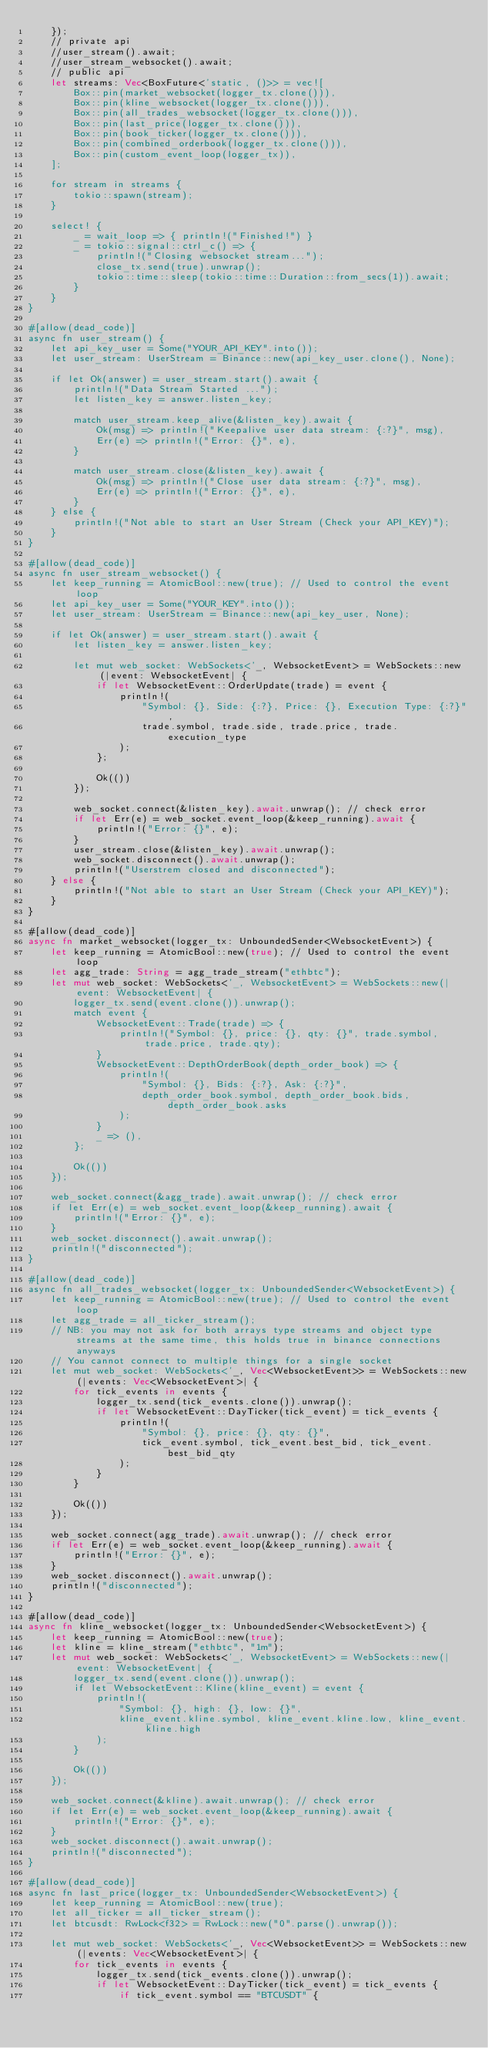Convert code to text. <code><loc_0><loc_0><loc_500><loc_500><_Rust_>    });
    // private api
    //user_stream().await;
    //user_stream_websocket().await;
    // public api
    let streams: Vec<BoxFuture<'static, ()>> = vec![
        Box::pin(market_websocket(logger_tx.clone())),
        Box::pin(kline_websocket(logger_tx.clone())),
        Box::pin(all_trades_websocket(logger_tx.clone())),
        Box::pin(last_price(logger_tx.clone())),
        Box::pin(book_ticker(logger_tx.clone())),
        Box::pin(combined_orderbook(logger_tx.clone())),
        Box::pin(custom_event_loop(logger_tx)),
    ];

    for stream in streams {
        tokio::spawn(stream);
    }

    select! {
        _ = wait_loop => { println!("Finished!") }
        _ = tokio::signal::ctrl_c() => {
            println!("Closing websocket stream...");
            close_tx.send(true).unwrap();
            tokio::time::sleep(tokio::time::Duration::from_secs(1)).await;
        }
    }
}

#[allow(dead_code)]
async fn user_stream() {
    let api_key_user = Some("YOUR_API_KEY".into());
    let user_stream: UserStream = Binance::new(api_key_user.clone(), None);

    if let Ok(answer) = user_stream.start().await {
        println!("Data Stream Started ...");
        let listen_key = answer.listen_key;

        match user_stream.keep_alive(&listen_key).await {
            Ok(msg) => println!("Keepalive user data stream: {:?}", msg),
            Err(e) => println!("Error: {}", e),
        }

        match user_stream.close(&listen_key).await {
            Ok(msg) => println!("Close user data stream: {:?}", msg),
            Err(e) => println!("Error: {}", e),
        }
    } else {
        println!("Not able to start an User Stream (Check your API_KEY)");
    }
}

#[allow(dead_code)]
async fn user_stream_websocket() {
    let keep_running = AtomicBool::new(true); // Used to control the event loop
    let api_key_user = Some("YOUR_KEY".into());
    let user_stream: UserStream = Binance::new(api_key_user, None);

    if let Ok(answer) = user_stream.start().await {
        let listen_key = answer.listen_key;

        let mut web_socket: WebSockets<'_, WebsocketEvent> = WebSockets::new(|event: WebsocketEvent| {
            if let WebsocketEvent::OrderUpdate(trade) = event {
                println!(
                    "Symbol: {}, Side: {:?}, Price: {}, Execution Type: {:?}",
                    trade.symbol, trade.side, trade.price, trade.execution_type
                );
            };

            Ok(())
        });

        web_socket.connect(&listen_key).await.unwrap(); // check error
        if let Err(e) = web_socket.event_loop(&keep_running).await {
            println!("Error: {}", e);
        }
        user_stream.close(&listen_key).await.unwrap();
        web_socket.disconnect().await.unwrap();
        println!("Userstrem closed and disconnected");
    } else {
        println!("Not able to start an User Stream (Check your API_KEY)");
    }
}

#[allow(dead_code)]
async fn market_websocket(logger_tx: UnboundedSender<WebsocketEvent>) {
    let keep_running = AtomicBool::new(true); // Used to control the event loop
    let agg_trade: String = agg_trade_stream("ethbtc");
    let mut web_socket: WebSockets<'_, WebsocketEvent> = WebSockets::new(|event: WebsocketEvent| {
        logger_tx.send(event.clone()).unwrap();
        match event {
            WebsocketEvent::Trade(trade) => {
                println!("Symbol: {}, price: {}, qty: {}", trade.symbol, trade.price, trade.qty);
            }
            WebsocketEvent::DepthOrderBook(depth_order_book) => {
                println!(
                    "Symbol: {}, Bids: {:?}, Ask: {:?}",
                    depth_order_book.symbol, depth_order_book.bids, depth_order_book.asks
                );
            }
            _ => (),
        };

        Ok(())
    });

    web_socket.connect(&agg_trade).await.unwrap(); // check error
    if let Err(e) = web_socket.event_loop(&keep_running).await {
        println!("Error: {}", e);
    }
    web_socket.disconnect().await.unwrap();
    println!("disconnected");
}

#[allow(dead_code)]
async fn all_trades_websocket(logger_tx: UnboundedSender<WebsocketEvent>) {
    let keep_running = AtomicBool::new(true); // Used to control the event loop
    let agg_trade = all_ticker_stream();
    // NB: you may not ask for both arrays type streams and object type streams at the same time, this holds true in binance connections anyways
    // You cannot connect to multiple things for a single socket
    let mut web_socket: WebSockets<'_, Vec<WebsocketEvent>> = WebSockets::new(|events: Vec<WebsocketEvent>| {
        for tick_events in events {
            logger_tx.send(tick_events.clone()).unwrap();
            if let WebsocketEvent::DayTicker(tick_event) = tick_events {
                println!(
                    "Symbol: {}, price: {}, qty: {}",
                    tick_event.symbol, tick_event.best_bid, tick_event.best_bid_qty
                );
            }
        }

        Ok(())
    });

    web_socket.connect(agg_trade).await.unwrap(); // check error
    if let Err(e) = web_socket.event_loop(&keep_running).await {
        println!("Error: {}", e);
    }
    web_socket.disconnect().await.unwrap();
    println!("disconnected");
}

#[allow(dead_code)]
async fn kline_websocket(logger_tx: UnboundedSender<WebsocketEvent>) {
    let keep_running = AtomicBool::new(true);
    let kline = kline_stream("ethbtc", "1m");
    let mut web_socket: WebSockets<'_, WebsocketEvent> = WebSockets::new(|event: WebsocketEvent| {
        logger_tx.send(event.clone()).unwrap();
        if let WebsocketEvent::Kline(kline_event) = event {
            println!(
                "Symbol: {}, high: {}, low: {}",
                kline_event.kline.symbol, kline_event.kline.low, kline_event.kline.high
            );
        }

        Ok(())
    });

    web_socket.connect(&kline).await.unwrap(); // check error
    if let Err(e) = web_socket.event_loop(&keep_running).await {
        println!("Error: {}", e);
    }
    web_socket.disconnect().await.unwrap();
    println!("disconnected");
}

#[allow(dead_code)]
async fn last_price(logger_tx: UnboundedSender<WebsocketEvent>) {
    let keep_running = AtomicBool::new(true);
    let all_ticker = all_ticker_stream();
    let btcusdt: RwLock<f32> = RwLock::new("0".parse().unwrap());

    let mut web_socket: WebSockets<'_, Vec<WebsocketEvent>> = WebSockets::new(|events: Vec<WebsocketEvent>| {
        for tick_events in events {
            logger_tx.send(tick_events.clone()).unwrap();
            if let WebsocketEvent::DayTicker(tick_event) = tick_events {
                if tick_event.symbol == "BTCUSDT" {</code> 